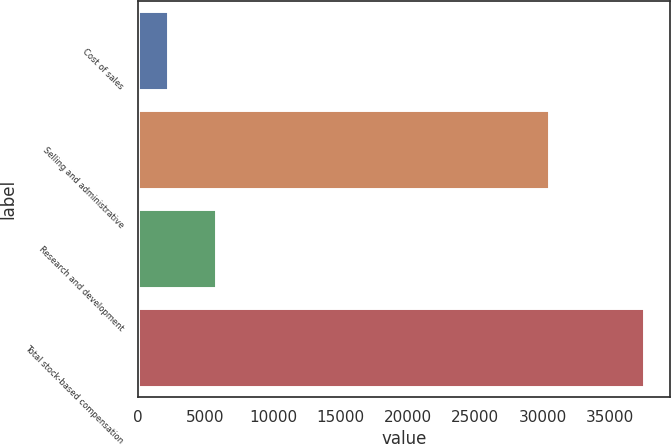Convert chart to OTSL. <chart><loc_0><loc_0><loc_500><loc_500><bar_chart><fcel>Cost of sales<fcel>Selling and administrative<fcel>Research and development<fcel>Total stock-based compensation<nl><fcel>2212<fcel>30443<fcel>5744.9<fcel>37541<nl></chart> 